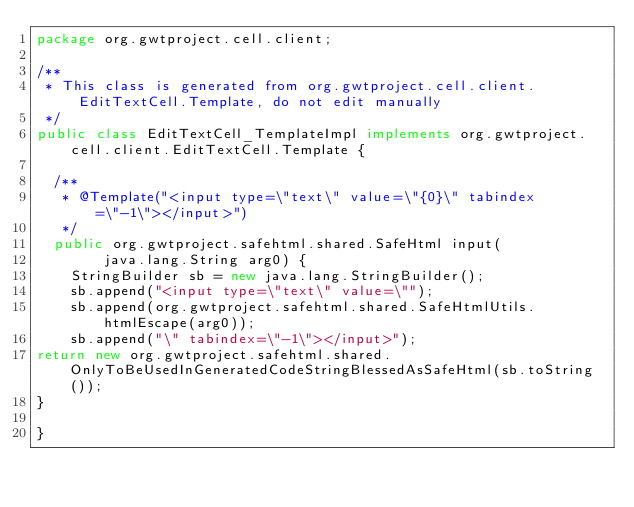Convert code to text. <code><loc_0><loc_0><loc_500><loc_500><_Java_>package org.gwtproject.cell.client;

/**
 * This class is generated from org.gwtproject.cell.client.EditTextCell.Template, do not edit manually
 */
public class EditTextCell_TemplateImpl implements org.gwtproject.cell.client.EditTextCell.Template {
  
  /**
   * @Template("<input type=\"text\" value=\"{0}\" tabindex=\"-1\"></input>")
   */
  public org.gwtproject.safehtml.shared.SafeHtml input(
        java.lang.String arg0) {
    StringBuilder sb = new java.lang.StringBuilder();
    sb.append("<input type=\"text\" value=\"");
    sb.append(org.gwtproject.safehtml.shared.SafeHtmlUtils.htmlEscape(arg0));
    sb.append("\" tabindex=\"-1\"></input>");
return new org.gwtproject.safehtml.shared.OnlyToBeUsedInGeneratedCodeStringBlessedAsSafeHtml(sb.toString());
}

}
</code> 